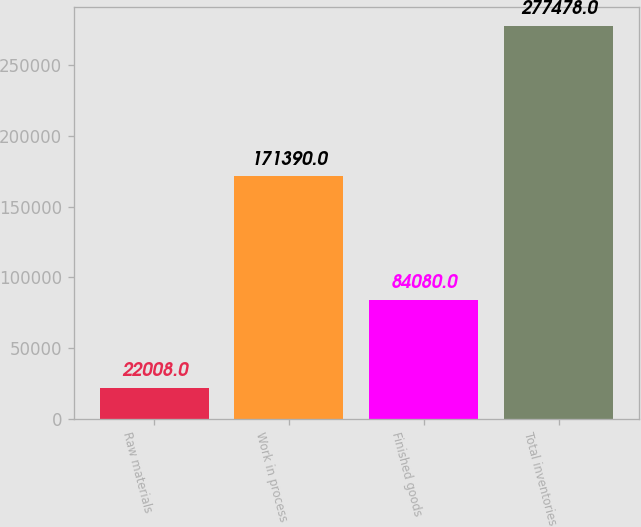Convert chart. <chart><loc_0><loc_0><loc_500><loc_500><bar_chart><fcel>Raw materials<fcel>Work in process<fcel>Finished goods<fcel>Total inventories<nl><fcel>22008<fcel>171390<fcel>84080<fcel>277478<nl></chart> 